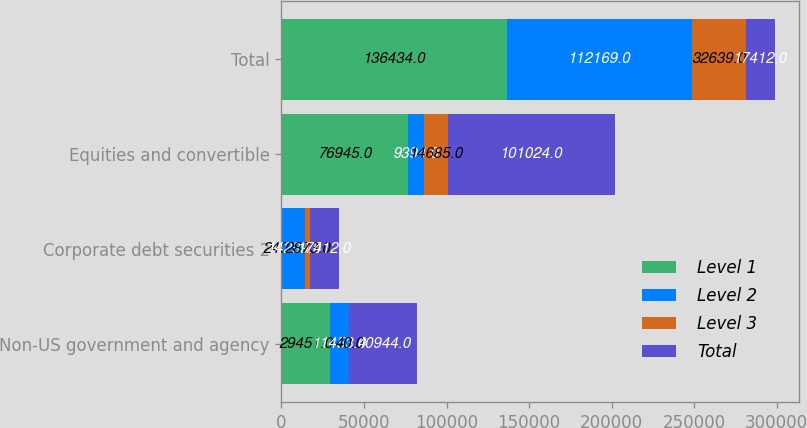Convert chart. <chart><loc_0><loc_0><loc_500><loc_500><stacked_bar_chart><ecel><fcel>Non-US government and agency<fcel>Corporate debt securities 2<fcel>Equities and convertible<fcel>Total<nl><fcel>Level 1<fcel>29451<fcel>240<fcel>76945<fcel>136434<nl><fcel>Level 2<fcel>11453<fcel>14299<fcel>9394<fcel>112169<nl><fcel>Level 3<fcel>40<fcel>2873<fcel>14685<fcel>32639<nl><fcel>Total<fcel>40944<fcel>17412<fcel>101024<fcel>17412<nl></chart> 